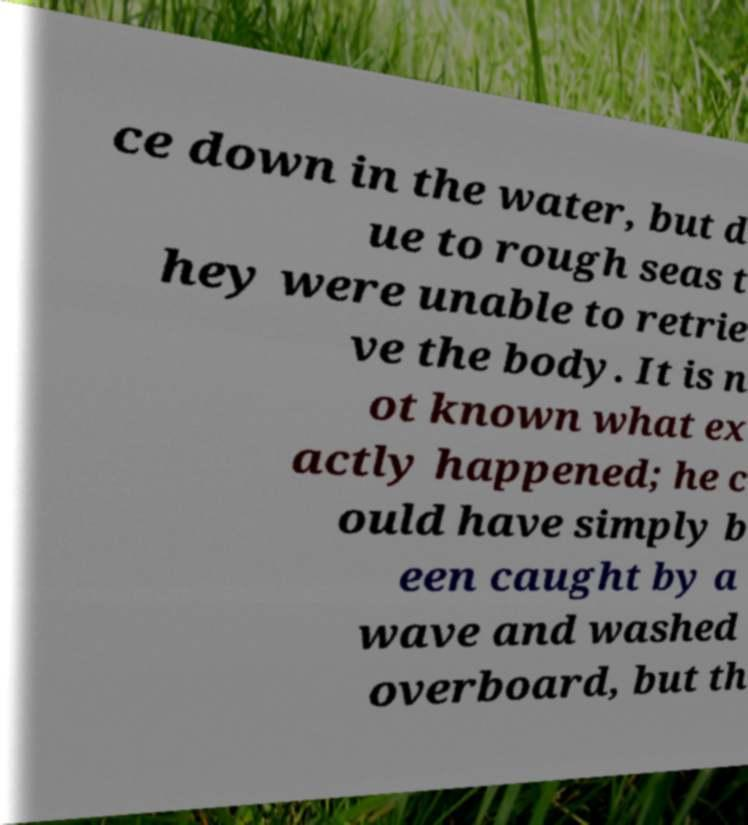I need the written content from this picture converted into text. Can you do that? ce down in the water, but d ue to rough seas t hey were unable to retrie ve the body. It is n ot known what ex actly happened; he c ould have simply b een caught by a wave and washed overboard, but th 